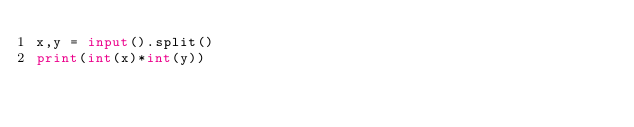Convert code to text. <code><loc_0><loc_0><loc_500><loc_500><_Python_>x,y = input().split()
print(int(x)*int(y))</code> 